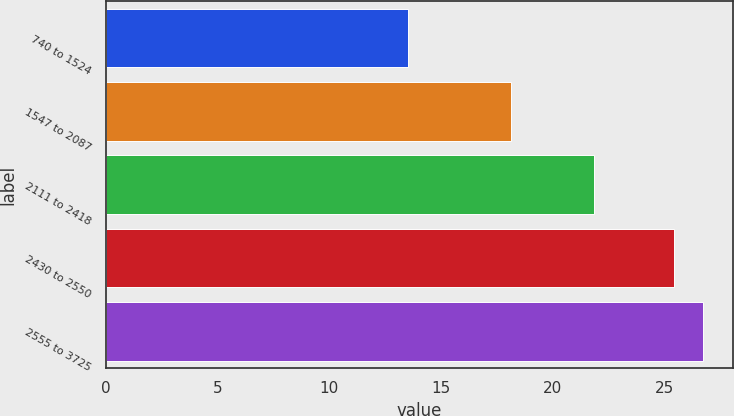<chart> <loc_0><loc_0><loc_500><loc_500><bar_chart><fcel>740 to 1524<fcel>1547 to 2087<fcel>2111 to 2418<fcel>2430 to 2550<fcel>2555 to 3725<nl><fcel>13.53<fcel>18.13<fcel>21.85<fcel>25.43<fcel>26.73<nl></chart> 